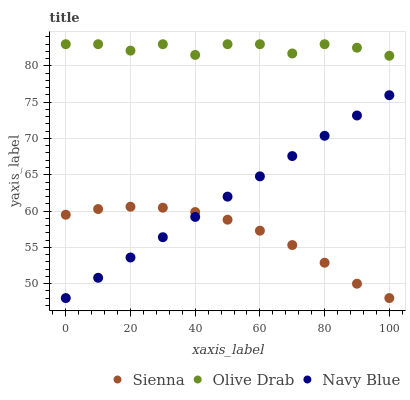Does Sienna have the minimum area under the curve?
Answer yes or no. Yes. Does Olive Drab have the maximum area under the curve?
Answer yes or no. Yes. Does Navy Blue have the minimum area under the curve?
Answer yes or no. No. Does Navy Blue have the maximum area under the curve?
Answer yes or no. No. Is Navy Blue the smoothest?
Answer yes or no. Yes. Is Olive Drab the roughest?
Answer yes or no. Yes. Is Olive Drab the smoothest?
Answer yes or no. No. Is Navy Blue the roughest?
Answer yes or no. No. Does Sienna have the lowest value?
Answer yes or no. Yes. Does Olive Drab have the lowest value?
Answer yes or no. No. Does Olive Drab have the highest value?
Answer yes or no. Yes. Does Navy Blue have the highest value?
Answer yes or no. No. Is Navy Blue less than Olive Drab?
Answer yes or no. Yes. Is Olive Drab greater than Sienna?
Answer yes or no. Yes. Does Sienna intersect Navy Blue?
Answer yes or no. Yes. Is Sienna less than Navy Blue?
Answer yes or no. No. Is Sienna greater than Navy Blue?
Answer yes or no. No. Does Navy Blue intersect Olive Drab?
Answer yes or no. No. 